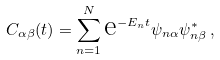<formula> <loc_0><loc_0><loc_500><loc_500>C _ { \alpha \beta } ( t ) = \sum _ { n = 1 } ^ { N } \text {e} ^ { - E _ { n } t } \psi _ { n \alpha } \psi _ { n \beta } ^ { * } \, ,</formula> 